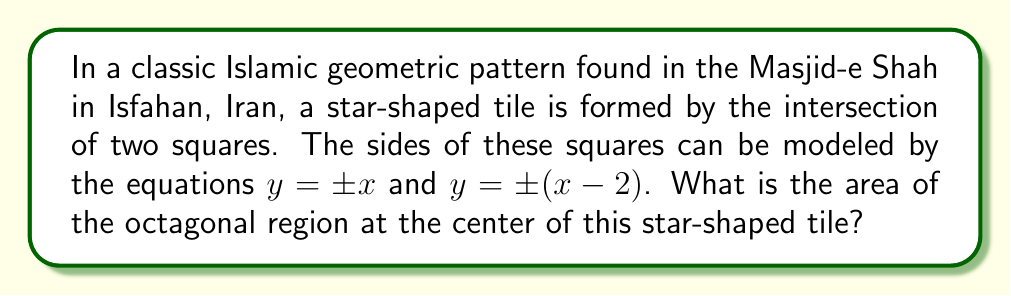Can you answer this question? Let's approach this step-by-step:

1) The equations $y = \pm x$ represent two lines that form a 45-degree angle with the x-axis, intersecting at the origin (0,0).

2) The equations $y = \pm (x - 2)$ represent two lines that are parallel to $y = \pm x$, but shifted 2 units to the right.

3) These four lines intersect to form an octagon at the center of the star shape.

4) To find the area of this octagon, we need to find its vertices. The vertices will be at the intersections of:
   $y = x$ and $y = x - 2$
   $y = x$ and $y = -(x - 2)$
   $y = -x$ and $y = x - 2$
   $y = -x$ and $y = -(x - 2)$

5) Solving these equations:
   $x = x - 2$ gives $x = 1, y = 1$
   $x = -(x - 2)$ gives $x = 1, y = 1$
   $-x = x - 2$ gives $x = 1, y = -1$
   $-x = -(x - 2)$ gives $x = 1, y = -1$

6) The octagon is symmetric, so we only need to calculate half of it and double the result.

7) The octagon can be divided into a rectangle (2 units wide and 2 units tall) and two triangles (each with base 1 and height 1).

8) Area of the rectangle: $2 * 2 = 4$
   Area of each triangle: $\frac{1 * 1}{2} = 0.5$
   Total area of half the octagon: $4 + 2(0.5) = 5$

9) Therefore, the total area of the octagon is $5 * 2 = 10$ square units.
Answer: $10$ square units 